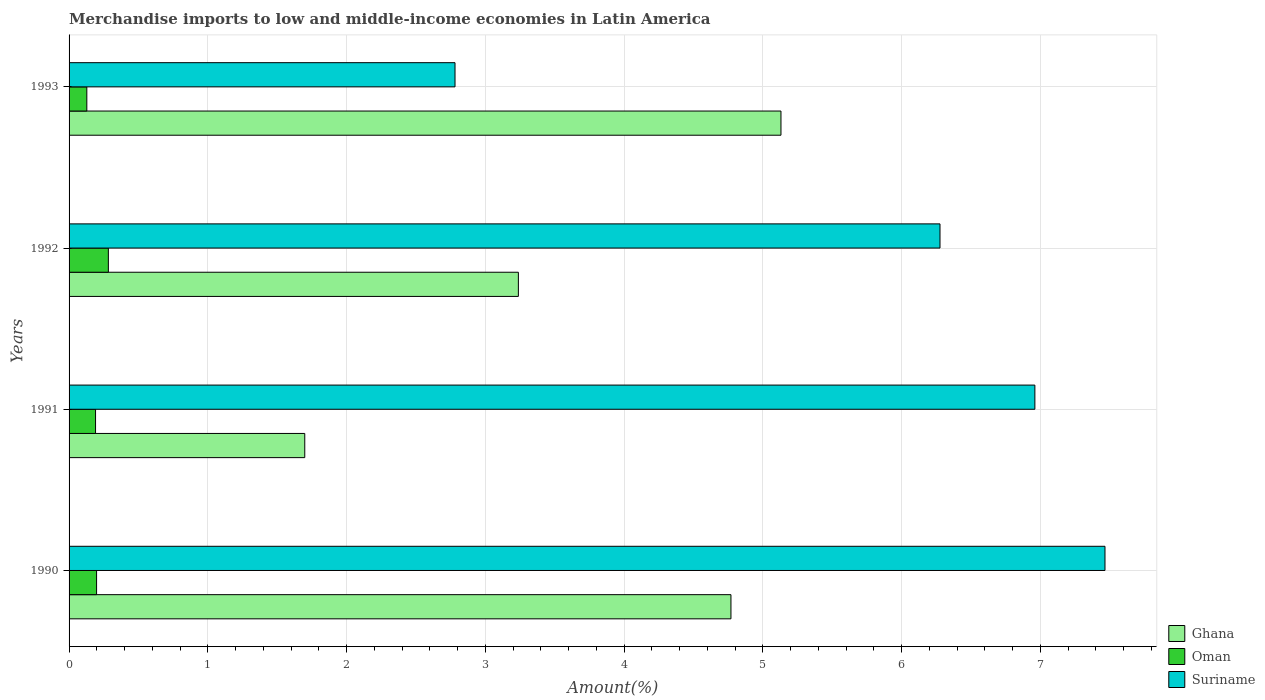How many bars are there on the 4th tick from the top?
Offer a terse response. 3. How many bars are there on the 2nd tick from the bottom?
Offer a terse response. 3. What is the label of the 4th group of bars from the top?
Offer a very short reply. 1990. What is the percentage of amount earned from merchandise imports in Ghana in 1992?
Provide a succinct answer. 3.24. Across all years, what is the maximum percentage of amount earned from merchandise imports in Suriname?
Offer a very short reply. 7.47. Across all years, what is the minimum percentage of amount earned from merchandise imports in Suriname?
Offer a very short reply. 2.78. In which year was the percentage of amount earned from merchandise imports in Ghana minimum?
Provide a short and direct response. 1991. What is the total percentage of amount earned from merchandise imports in Oman in the graph?
Offer a terse response. 0.8. What is the difference between the percentage of amount earned from merchandise imports in Oman in 1992 and that in 1993?
Ensure brevity in your answer.  0.16. What is the difference between the percentage of amount earned from merchandise imports in Ghana in 1993 and the percentage of amount earned from merchandise imports in Oman in 1991?
Offer a terse response. 4.94. What is the average percentage of amount earned from merchandise imports in Oman per year?
Offer a terse response. 0.2. In the year 1990, what is the difference between the percentage of amount earned from merchandise imports in Oman and percentage of amount earned from merchandise imports in Ghana?
Provide a short and direct response. -4.57. In how many years, is the percentage of amount earned from merchandise imports in Ghana greater than 2.8 %?
Give a very brief answer. 3. What is the ratio of the percentage of amount earned from merchandise imports in Suriname in 1990 to that in 1992?
Your answer should be very brief. 1.19. What is the difference between the highest and the second highest percentage of amount earned from merchandise imports in Ghana?
Keep it short and to the point. 0.36. What is the difference between the highest and the lowest percentage of amount earned from merchandise imports in Suriname?
Offer a terse response. 4.68. Is the sum of the percentage of amount earned from merchandise imports in Oman in 1991 and 1992 greater than the maximum percentage of amount earned from merchandise imports in Ghana across all years?
Offer a terse response. No. What does the 2nd bar from the top in 1993 represents?
Provide a short and direct response. Oman. What does the 3rd bar from the bottom in 1991 represents?
Your response must be concise. Suriname. Is it the case that in every year, the sum of the percentage of amount earned from merchandise imports in Ghana and percentage of amount earned from merchandise imports in Oman is greater than the percentage of amount earned from merchandise imports in Suriname?
Ensure brevity in your answer.  No. Where does the legend appear in the graph?
Provide a succinct answer. Bottom right. How many legend labels are there?
Give a very brief answer. 3. How are the legend labels stacked?
Provide a short and direct response. Vertical. What is the title of the graph?
Offer a very short reply. Merchandise imports to low and middle-income economies in Latin America. Does "Slovak Republic" appear as one of the legend labels in the graph?
Offer a very short reply. No. What is the label or title of the X-axis?
Keep it short and to the point. Amount(%). What is the label or title of the Y-axis?
Ensure brevity in your answer.  Years. What is the Amount(%) of Ghana in 1990?
Your answer should be very brief. 4.77. What is the Amount(%) of Oman in 1990?
Offer a terse response. 0.2. What is the Amount(%) in Suriname in 1990?
Keep it short and to the point. 7.47. What is the Amount(%) of Ghana in 1991?
Give a very brief answer. 1.7. What is the Amount(%) in Oman in 1991?
Provide a succinct answer. 0.19. What is the Amount(%) in Suriname in 1991?
Provide a succinct answer. 6.96. What is the Amount(%) in Ghana in 1992?
Provide a short and direct response. 3.24. What is the Amount(%) of Oman in 1992?
Your response must be concise. 0.28. What is the Amount(%) in Suriname in 1992?
Provide a succinct answer. 6.28. What is the Amount(%) in Ghana in 1993?
Ensure brevity in your answer.  5.13. What is the Amount(%) of Oman in 1993?
Offer a terse response. 0.13. What is the Amount(%) in Suriname in 1993?
Your response must be concise. 2.78. Across all years, what is the maximum Amount(%) of Ghana?
Give a very brief answer. 5.13. Across all years, what is the maximum Amount(%) of Oman?
Offer a very short reply. 0.28. Across all years, what is the maximum Amount(%) of Suriname?
Your response must be concise. 7.47. Across all years, what is the minimum Amount(%) in Ghana?
Ensure brevity in your answer.  1.7. Across all years, what is the minimum Amount(%) of Oman?
Your answer should be very brief. 0.13. Across all years, what is the minimum Amount(%) in Suriname?
Your answer should be very brief. 2.78. What is the total Amount(%) of Ghana in the graph?
Ensure brevity in your answer.  14.84. What is the total Amount(%) of Oman in the graph?
Make the answer very short. 0.8. What is the total Amount(%) of Suriname in the graph?
Your response must be concise. 23.49. What is the difference between the Amount(%) of Ghana in 1990 and that in 1991?
Your answer should be very brief. 3.07. What is the difference between the Amount(%) in Oman in 1990 and that in 1991?
Provide a short and direct response. 0.01. What is the difference between the Amount(%) of Suriname in 1990 and that in 1991?
Make the answer very short. 0.51. What is the difference between the Amount(%) of Ghana in 1990 and that in 1992?
Keep it short and to the point. 1.53. What is the difference between the Amount(%) of Oman in 1990 and that in 1992?
Your answer should be compact. -0.09. What is the difference between the Amount(%) of Suriname in 1990 and that in 1992?
Make the answer very short. 1.19. What is the difference between the Amount(%) in Ghana in 1990 and that in 1993?
Your answer should be very brief. -0.36. What is the difference between the Amount(%) in Oman in 1990 and that in 1993?
Your response must be concise. 0.07. What is the difference between the Amount(%) in Suriname in 1990 and that in 1993?
Provide a succinct answer. 4.68. What is the difference between the Amount(%) of Ghana in 1991 and that in 1992?
Provide a short and direct response. -1.54. What is the difference between the Amount(%) in Oman in 1991 and that in 1992?
Ensure brevity in your answer.  -0.09. What is the difference between the Amount(%) of Suriname in 1991 and that in 1992?
Give a very brief answer. 0.68. What is the difference between the Amount(%) in Ghana in 1991 and that in 1993?
Provide a succinct answer. -3.43. What is the difference between the Amount(%) of Oman in 1991 and that in 1993?
Provide a succinct answer. 0.06. What is the difference between the Amount(%) in Suriname in 1991 and that in 1993?
Provide a succinct answer. 4.18. What is the difference between the Amount(%) in Ghana in 1992 and that in 1993?
Ensure brevity in your answer.  -1.89. What is the difference between the Amount(%) of Oman in 1992 and that in 1993?
Provide a succinct answer. 0.16. What is the difference between the Amount(%) in Suriname in 1992 and that in 1993?
Your answer should be very brief. 3.5. What is the difference between the Amount(%) in Ghana in 1990 and the Amount(%) in Oman in 1991?
Provide a short and direct response. 4.58. What is the difference between the Amount(%) in Ghana in 1990 and the Amount(%) in Suriname in 1991?
Offer a very short reply. -2.19. What is the difference between the Amount(%) in Oman in 1990 and the Amount(%) in Suriname in 1991?
Your answer should be compact. -6.76. What is the difference between the Amount(%) of Ghana in 1990 and the Amount(%) of Oman in 1992?
Your answer should be very brief. 4.49. What is the difference between the Amount(%) in Ghana in 1990 and the Amount(%) in Suriname in 1992?
Make the answer very short. -1.51. What is the difference between the Amount(%) in Oman in 1990 and the Amount(%) in Suriname in 1992?
Ensure brevity in your answer.  -6.08. What is the difference between the Amount(%) of Ghana in 1990 and the Amount(%) of Oman in 1993?
Provide a succinct answer. 4.64. What is the difference between the Amount(%) of Ghana in 1990 and the Amount(%) of Suriname in 1993?
Offer a very short reply. 1.99. What is the difference between the Amount(%) in Oman in 1990 and the Amount(%) in Suriname in 1993?
Your answer should be very brief. -2.58. What is the difference between the Amount(%) in Ghana in 1991 and the Amount(%) in Oman in 1992?
Your response must be concise. 1.42. What is the difference between the Amount(%) of Ghana in 1991 and the Amount(%) of Suriname in 1992?
Provide a short and direct response. -4.58. What is the difference between the Amount(%) of Oman in 1991 and the Amount(%) of Suriname in 1992?
Offer a very short reply. -6.09. What is the difference between the Amount(%) in Ghana in 1991 and the Amount(%) in Oman in 1993?
Offer a terse response. 1.57. What is the difference between the Amount(%) in Ghana in 1991 and the Amount(%) in Suriname in 1993?
Your response must be concise. -1.08. What is the difference between the Amount(%) of Oman in 1991 and the Amount(%) of Suriname in 1993?
Keep it short and to the point. -2.59. What is the difference between the Amount(%) in Ghana in 1992 and the Amount(%) in Oman in 1993?
Make the answer very short. 3.11. What is the difference between the Amount(%) in Ghana in 1992 and the Amount(%) in Suriname in 1993?
Your answer should be compact. 0.46. What is the difference between the Amount(%) in Oman in 1992 and the Amount(%) in Suriname in 1993?
Offer a terse response. -2.5. What is the average Amount(%) of Ghana per year?
Offer a terse response. 3.71. What is the average Amount(%) of Oman per year?
Make the answer very short. 0.2. What is the average Amount(%) of Suriname per year?
Offer a terse response. 5.87. In the year 1990, what is the difference between the Amount(%) of Ghana and Amount(%) of Oman?
Keep it short and to the point. 4.57. In the year 1990, what is the difference between the Amount(%) in Ghana and Amount(%) in Suriname?
Your answer should be compact. -2.7. In the year 1990, what is the difference between the Amount(%) in Oman and Amount(%) in Suriname?
Provide a succinct answer. -7.27. In the year 1991, what is the difference between the Amount(%) in Ghana and Amount(%) in Oman?
Give a very brief answer. 1.51. In the year 1991, what is the difference between the Amount(%) in Ghana and Amount(%) in Suriname?
Offer a very short reply. -5.26. In the year 1991, what is the difference between the Amount(%) of Oman and Amount(%) of Suriname?
Ensure brevity in your answer.  -6.77. In the year 1992, what is the difference between the Amount(%) of Ghana and Amount(%) of Oman?
Give a very brief answer. 2.96. In the year 1992, what is the difference between the Amount(%) of Ghana and Amount(%) of Suriname?
Keep it short and to the point. -3.04. In the year 1992, what is the difference between the Amount(%) of Oman and Amount(%) of Suriname?
Offer a terse response. -5.99. In the year 1993, what is the difference between the Amount(%) in Ghana and Amount(%) in Oman?
Your answer should be compact. 5. In the year 1993, what is the difference between the Amount(%) in Ghana and Amount(%) in Suriname?
Give a very brief answer. 2.35. In the year 1993, what is the difference between the Amount(%) of Oman and Amount(%) of Suriname?
Offer a very short reply. -2.65. What is the ratio of the Amount(%) in Ghana in 1990 to that in 1991?
Offer a terse response. 2.81. What is the ratio of the Amount(%) of Oman in 1990 to that in 1991?
Your response must be concise. 1.04. What is the ratio of the Amount(%) in Suriname in 1990 to that in 1991?
Offer a very short reply. 1.07. What is the ratio of the Amount(%) of Ghana in 1990 to that in 1992?
Provide a succinct answer. 1.47. What is the ratio of the Amount(%) of Oman in 1990 to that in 1992?
Offer a very short reply. 0.7. What is the ratio of the Amount(%) in Suriname in 1990 to that in 1992?
Offer a terse response. 1.19. What is the ratio of the Amount(%) of Ghana in 1990 to that in 1993?
Your answer should be very brief. 0.93. What is the ratio of the Amount(%) of Oman in 1990 to that in 1993?
Your response must be concise. 1.55. What is the ratio of the Amount(%) of Suriname in 1990 to that in 1993?
Ensure brevity in your answer.  2.68. What is the ratio of the Amount(%) in Ghana in 1991 to that in 1992?
Make the answer very short. 0.52. What is the ratio of the Amount(%) of Oman in 1991 to that in 1992?
Keep it short and to the point. 0.67. What is the ratio of the Amount(%) of Suriname in 1991 to that in 1992?
Your response must be concise. 1.11. What is the ratio of the Amount(%) of Ghana in 1991 to that in 1993?
Provide a succinct answer. 0.33. What is the ratio of the Amount(%) in Oman in 1991 to that in 1993?
Make the answer very short. 1.49. What is the ratio of the Amount(%) in Suriname in 1991 to that in 1993?
Provide a short and direct response. 2.5. What is the ratio of the Amount(%) in Ghana in 1992 to that in 1993?
Offer a terse response. 0.63. What is the ratio of the Amount(%) in Oman in 1992 to that in 1993?
Give a very brief answer. 2.21. What is the ratio of the Amount(%) of Suriname in 1992 to that in 1993?
Make the answer very short. 2.26. What is the difference between the highest and the second highest Amount(%) in Ghana?
Your answer should be compact. 0.36. What is the difference between the highest and the second highest Amount(%) in Oman?
Offer a terse response. 0.09. What is the difference between the highest and the second highest Amount(%) of Suriname?
Make the answer very short. 0.51. What is the difference between the highest and the lowest Amount(%) of Ghana?
Make the answer very short. 3.43. What is the difference between the highest and the lowest Amount(%) in Oman?
Your response must be concise. 0.16. What is the difference between the highest and the lowest Amount(%) of Suriname?
Provide a short and direct response. 4.68. 